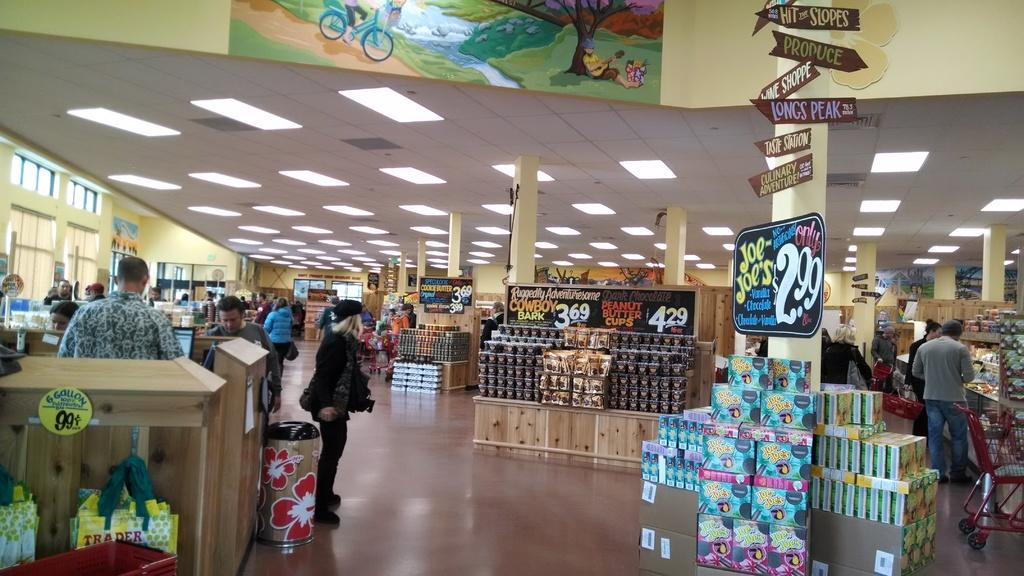<image>
Describe the image concisely. the inside of a trader joe's with stacks of products and a sign advertising joe-joes 